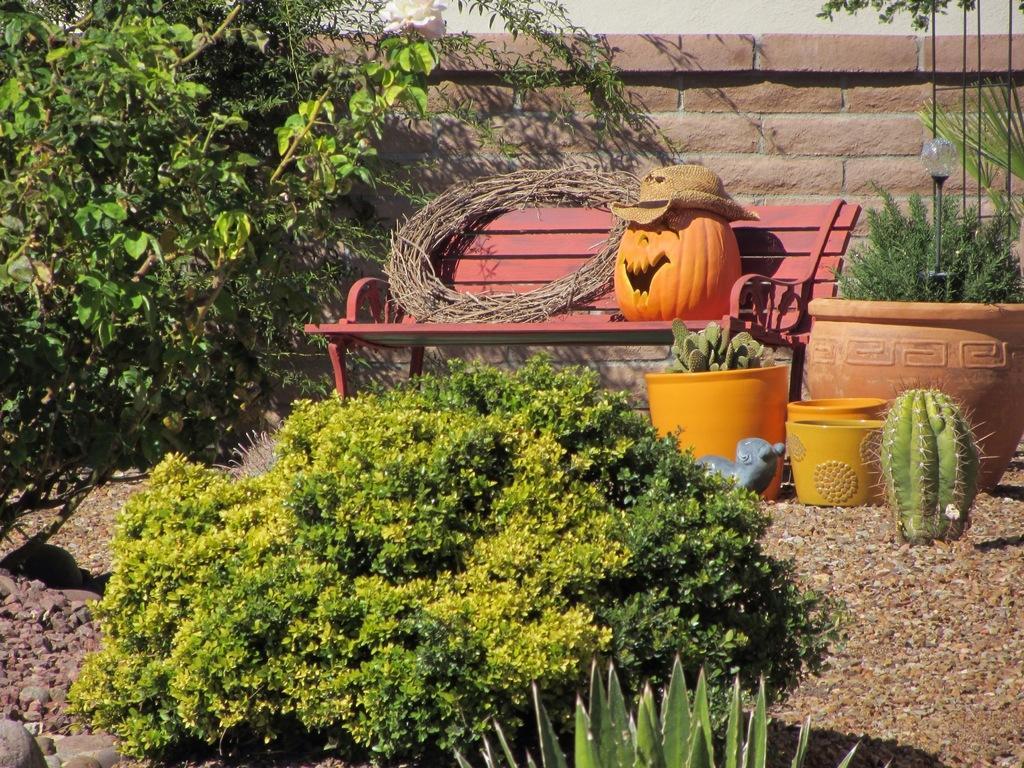How would you summarize this image in a sentence or two? At the bottom of the picture, we see the shrubs and the stones. On the right side, we see a cactus plant. Behind that, we see the flower pots in yellow color. Behind that, we see a plant pot and a light pole. In the middle, we see a bench on which carved pumpkin and a wooden thing are placed. On the left side, we see the trees. In the background, we see a wall which is made up of bricks. 